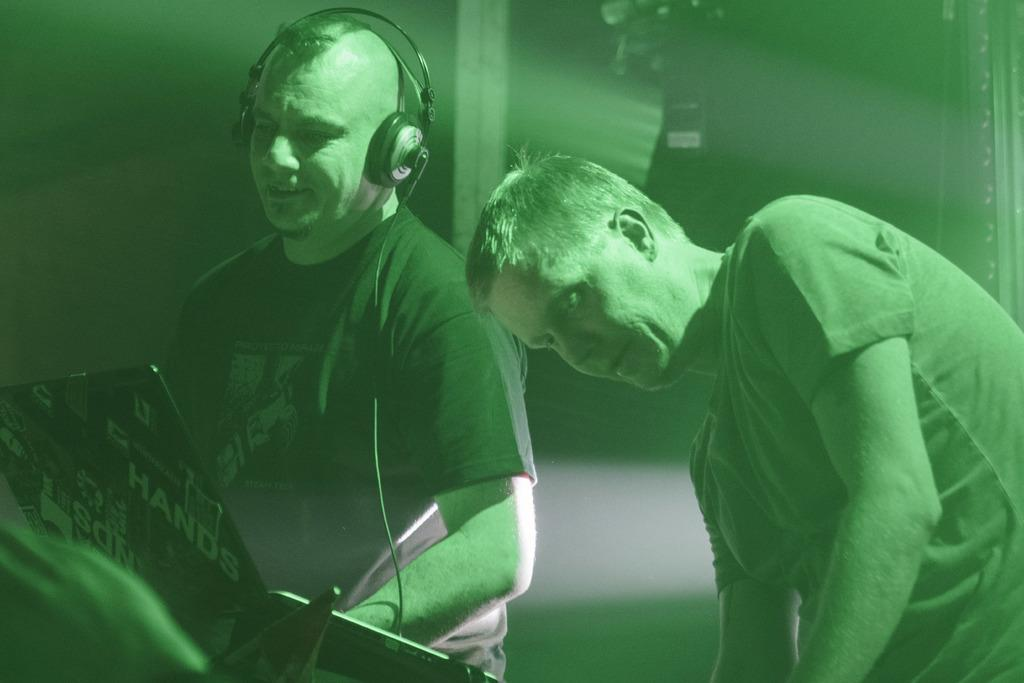How many people are in the image? There are two people in the image. What is one person wearing that is visible in the image? One person is wearing a headset. What are the people looking at in the image? The people are looking at boards. Can you describe the background of the image? The background of the image is blurred. What type of bead is being used to measure time in the image? There is no bead or time-measuring device present in the image. Where is the place where the people are supposed to meet in the image? The image does not show a specific place where the people are supposed to meet. 